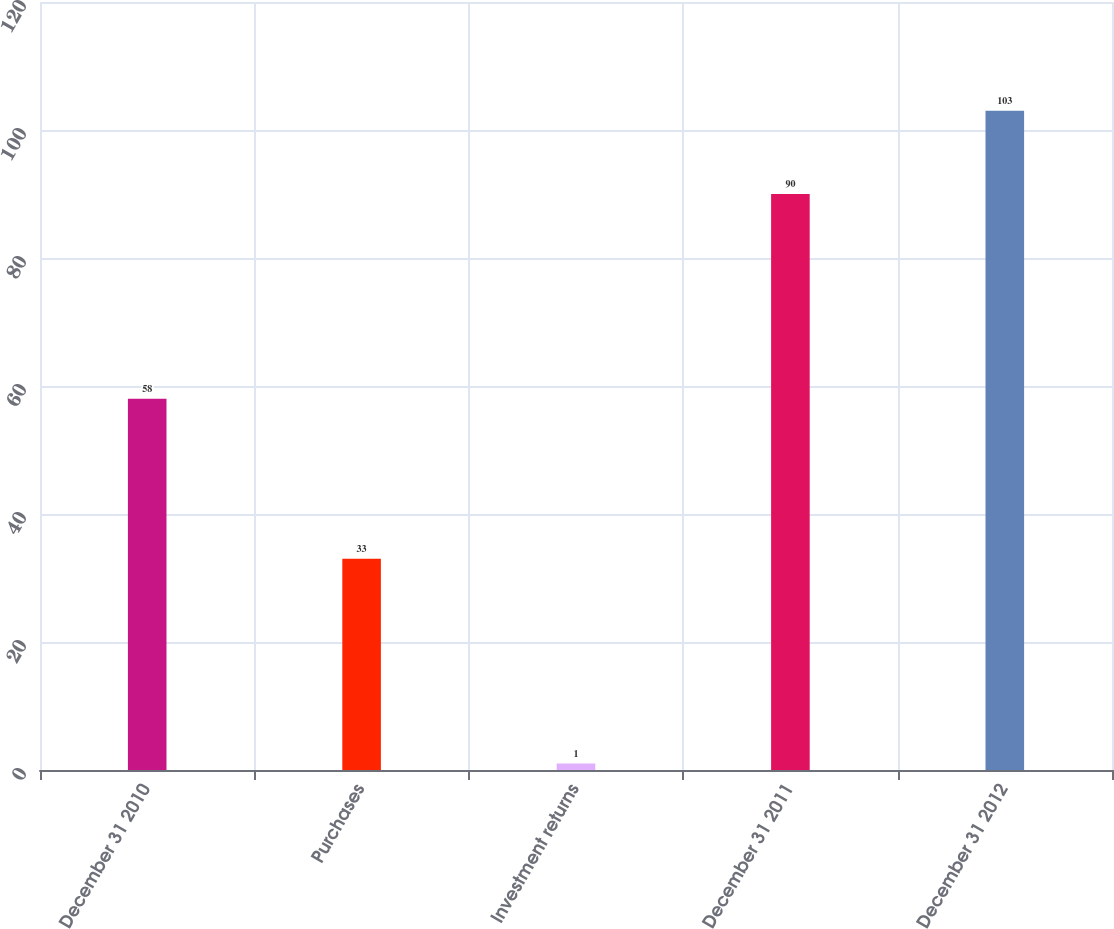<chart> <loc_0><loc_0><loc_500><loc_500><bar_chart><fcel>December 31 2010<fcel>Purchases<fcel>Investment returns<fcel>December 31 2011<fcel>December 31 2012<nl><fcel>58<fcel>33<fcel>1<fcel>90<fcel>103<nl></chart> 